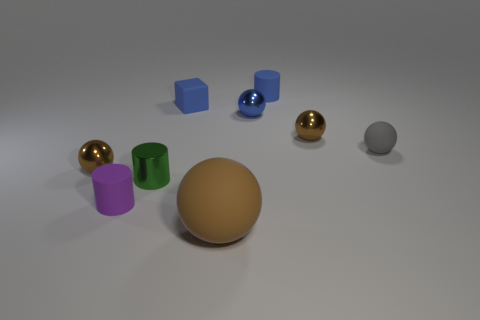Could you infer anything about the lighting in this scene? The lighting in the scene appears to be coming from the upper left side, as indicated by the shadows cast towards the right. The diffuse nature of the shadows suggests a soft, perhaps overcast light source, which gives the image a calm and even tone. 